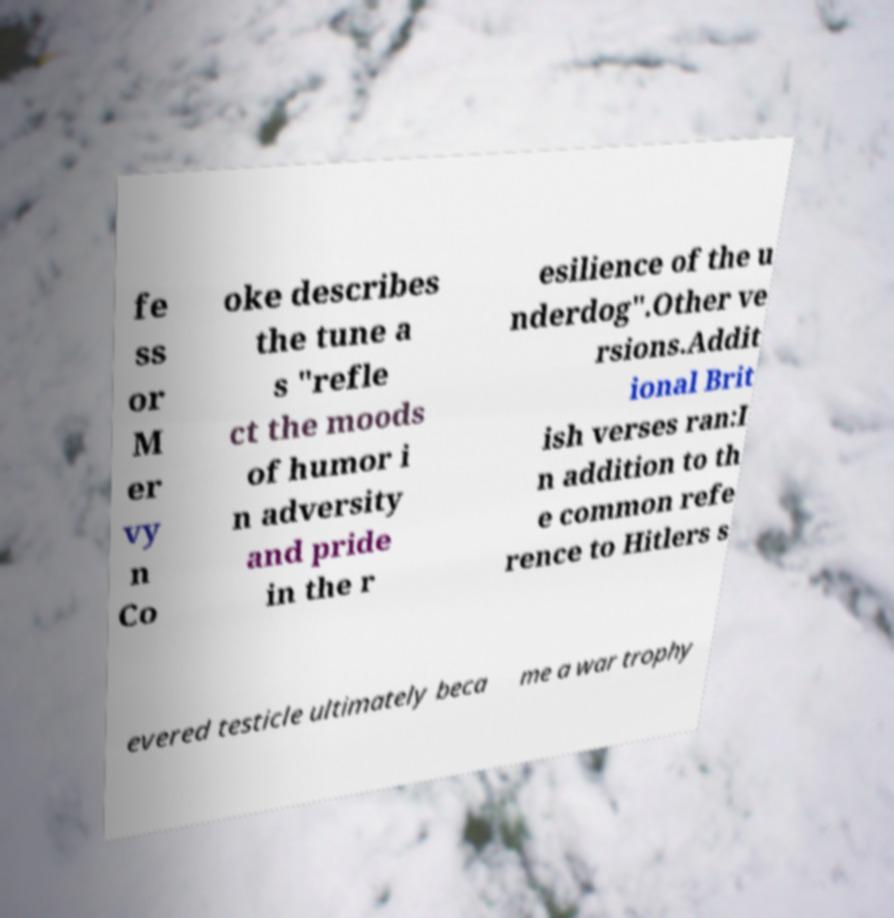Could you assist in decoding the text presented in this image and type it out clearly? fe ss or M er vy n Co oke describes the tune a s "refle ct the moods of humor i n adversity and pride in the r esilience of the u nderdog".Other ve rsions.Addit ional Brit ish verses ran:I n addition to th e common refe rence to Hitlers s evered testicle ultimately beca me a war trophy 